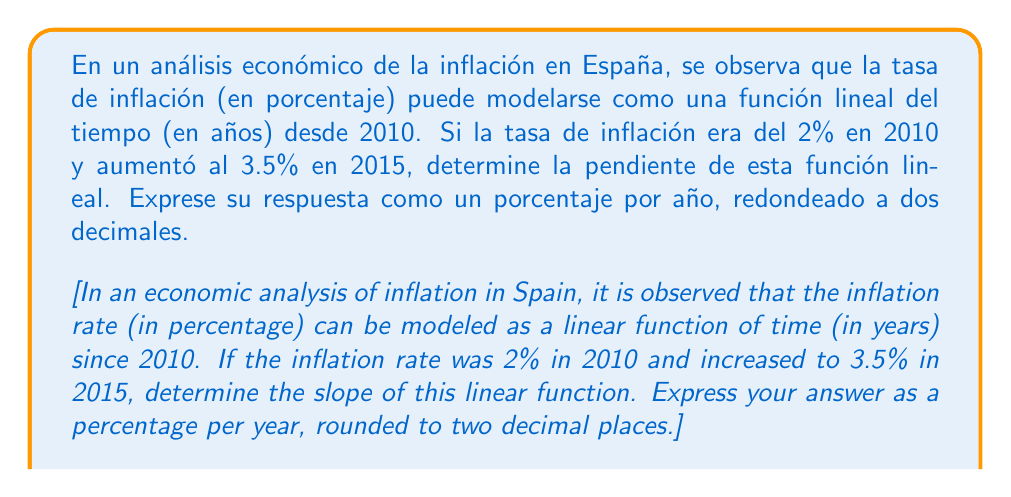Solve this math problem. Para resolver este problema, seguiremos estos pasos:

1) Identificar los puntos:
   - En 2010 (x₁ = 0), la tasa de inflación era y₁ = 2%
   - En 2015 (x₂ = 5), la tasa de inflación era y₂ = 3.5%

2) Utilizar la fórmula de la pendiente:
   $$m = \frac{y_2 - y_1}{x_2 - x_1}$$

3) Sustituir los valores:
   $$m = \frac{3.5\% - 2\%}{5 - 0} = \frac{1.5\%}{5}$$

4) Realizar la división:
   $$m = 0.3\% \text{ por año}$$

5) Redondear a dos decimales:
   $$m = 0.30\% \text{ por año}$$

La pendiente representa el cambio en la tasa de inflación por cada año que pasa. Un valor positivo indica que la inflación está aumentando con el tiempo.
Answer: $0.30\%$ por año 